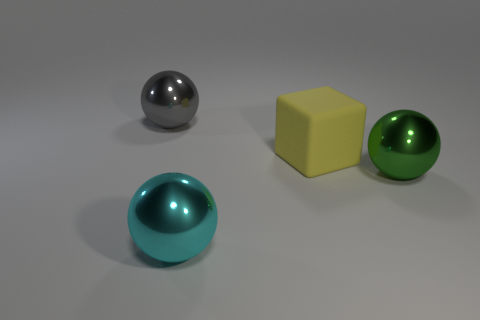What number of other objects are the same size as the gray metal object?
Your response must be concise. 3. Is there anything else that has the same shape as the yellow thing?
Your response must be concise. No. There is a ball that is right of the yellow rubber block; what is its material?
Provide a succinct answer. Metal. How many large cubes have the same material as the big cyan thing?
Your answer should be compact. 0. What number of other rubber objects are the same color as the big matte thing?
Your response must be concise. 0. What number of objects are either big things behind the cyan object or balls that are in front of the yellow block?
Your response must be concise. 4. Is the number of large gray shiny spheres that are on the right side of the yellow matte object less than the number of brown matte balls?
Provide a succinct answer. No. Is there a green shiny sphere of the same size as the cyan metal ball?
Offer a very short reply. Yes. What is the color of the big cube?
Give a very brief answer. Yellow. Do the gray shiny thing and the yellow matte object have the same size?
Offer a terse response. Yes. 